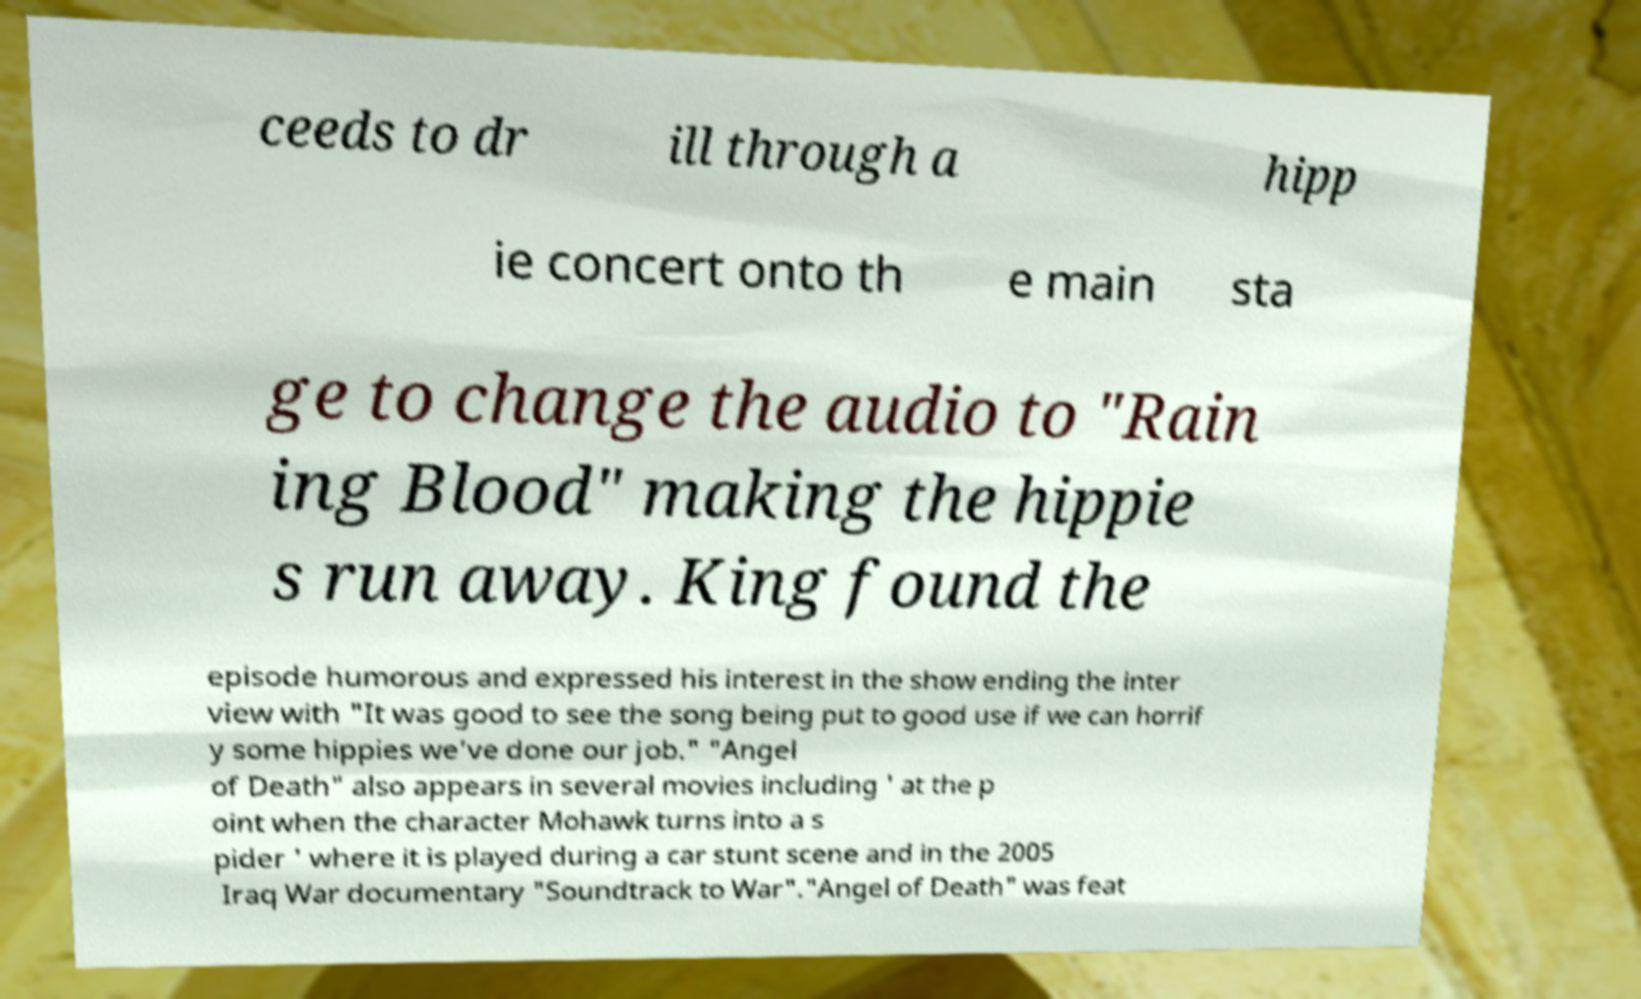Please identify and transcribe the text found in this image. ceeds to dr ill through a hipp ie concert onto th e main sta ge to change the audio to "Rain ing Blood" making the hippie s run away. King found the episode humorous and expressed his interest in the show ending the inter view with "It was good to see the song being put to good use if we can horrif y some hippies we've done our job." "Angel of Death" also appears in several movies including ' at the p oint when the character Mohawk turns into a s pider ' where it is played during a car stunt scene and in the 2005 Iraq War documentary "Soundtrack to War"."Angel of Death" was feat 